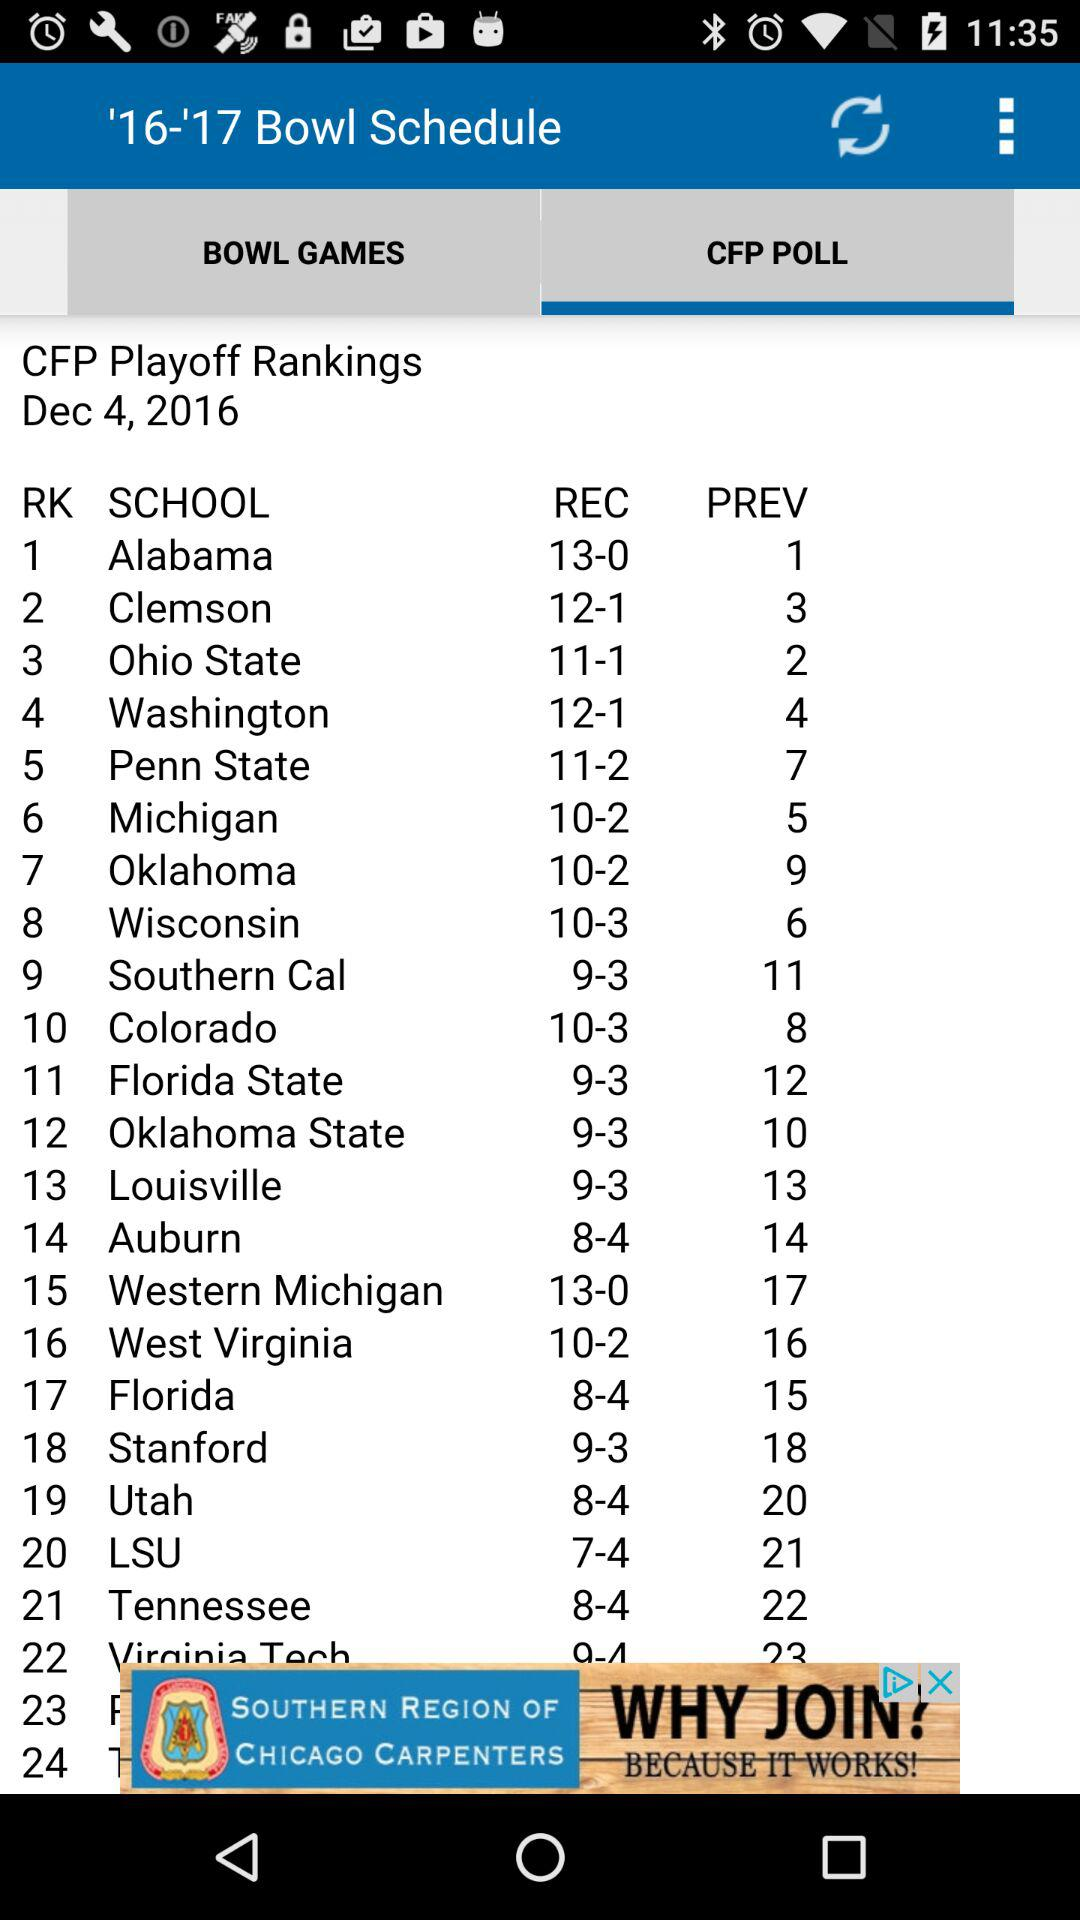Which school ranks first? The school is Alabama. 